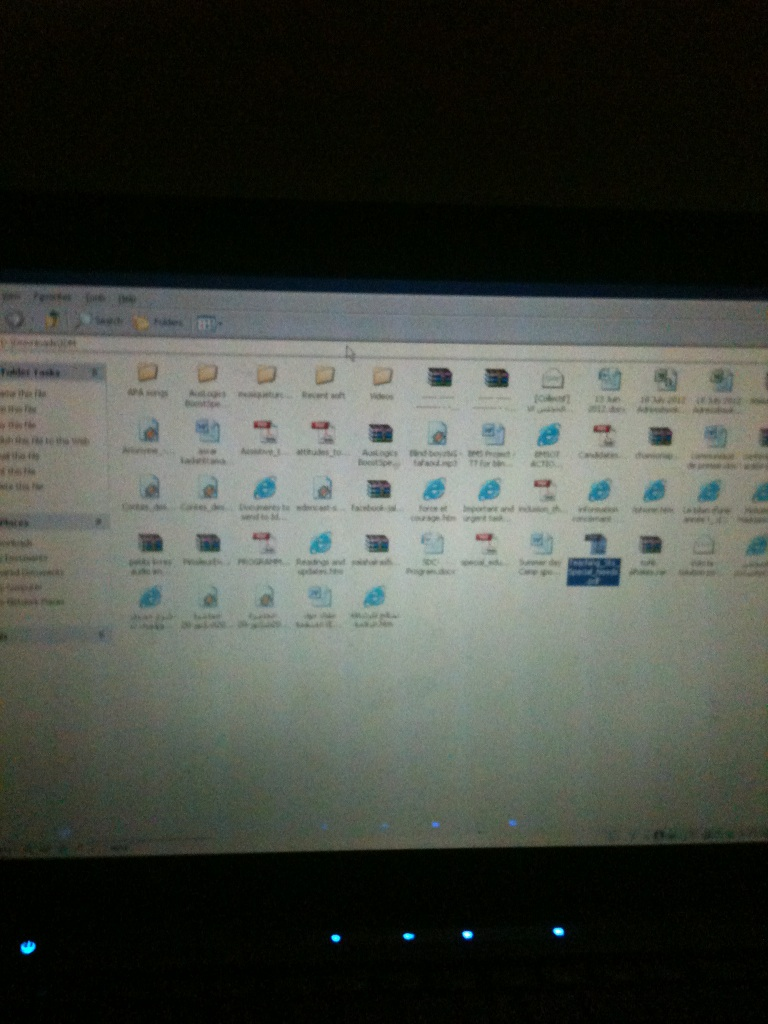What hidden stories or secrets do you think are behind these files? Behind these files could be fascinating stories or secrets about the owner's life and activities. The academic-related file names might reveal their educational journey, research work, or important assignments. Program installers could indicate their interest in specific software tools and applications, giving insight into their hobbies or professional expertise. Personal document filenames could contain memories, critical work, or plans unsurfaced yet, creating a window into their digital footprint. 